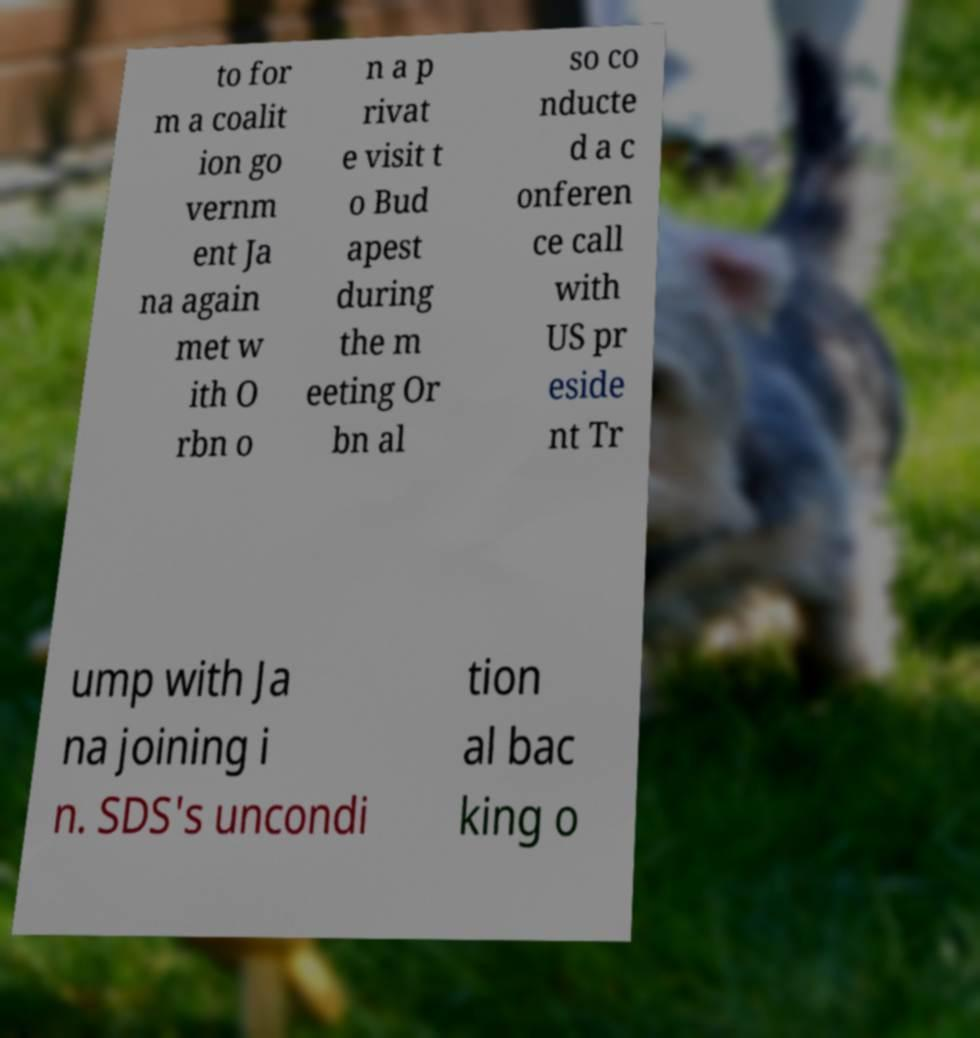What messages or text are displayed in this image? I need them in a readable, typed format. to for m a coalit ion go vernm ent Ja na again met w ith O rbn o n a p rivat e visit t o Bud apest during the m eeting Or bn al so co nducte d a c onferen ce call with US pr eside nt Tr ump with Ja na joining i n. SDS's uncondi tion al bac king o 